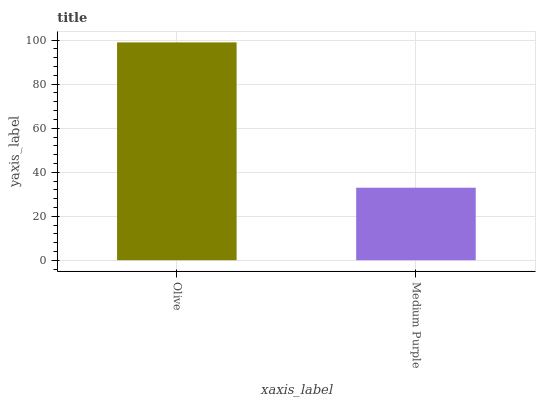Is Medium Purple the minimum?
Answer yes or no. Yes. Is Olive the maximum?
Answer yes or no. Yes. Is Medium Purple the maximum?
Answer yes or no. No. Is Olive greater than Medium Purple?
Answer yes or no. Yes. Is Medium Purple less than Olive?
Answer yes or no. Yes. Is Medium Purple greater than Olive?
Answer yes or no. No. Is Olive less than Medium Purple?
Answer yes or no. No. Is Olive the high median?
Answer yes or no. Yes. Is Medium Purple the low median?
Answer yes or no. Yes. Is Medium Purple the high median?
Answer yes or no. No. Is Olive the low median?
Answer yes or no. No. 